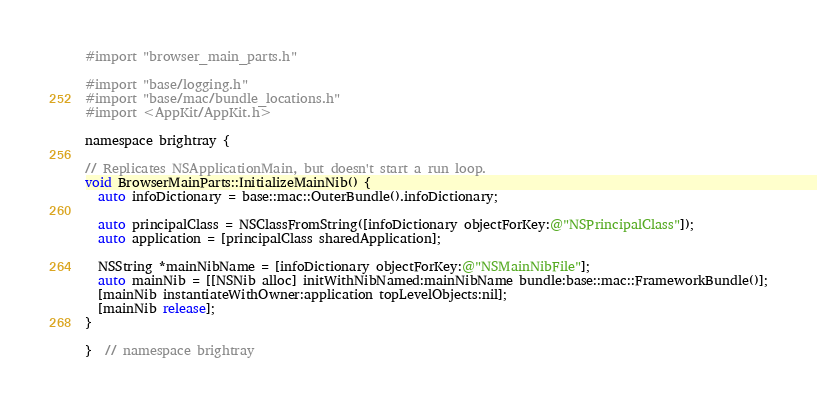Convert code to text. <code><loc_0><loc_0><loc_500><loc_500><_ObjectiveC_>#import "browser_main_parts.h"

#import "base/logging.h"
#import "base/mac/bundle_locations.h"
#import <AppKit/AppKit.h>

namespace brightray {

// Replicates NSApplicationMain, but doesn't start a run loop.
void BrowserMainParts::InitializeMainNib() {
  auto infoDictionary = base::mac::OuterBundle().infoDictionary;

  auto principalClass = NSClassFromString([infoDictionary objectForKey:@"NSPrincipalClass"]);
  auto application = [principalClass sharedApplication];

  NSString *mainNibName = [infoDictionary objectForKey:@"NSMainNibFile"];
  auto mainNib = [[NSNib alloc] initWithNibNamed:mainNibName bundle:base::mac::FrameworkBundle()];
  [mainNib instantiateWithOwner:application topLevelObjects:nil];
  [mainNib release];
}

}  // namespace brightray
</code> 